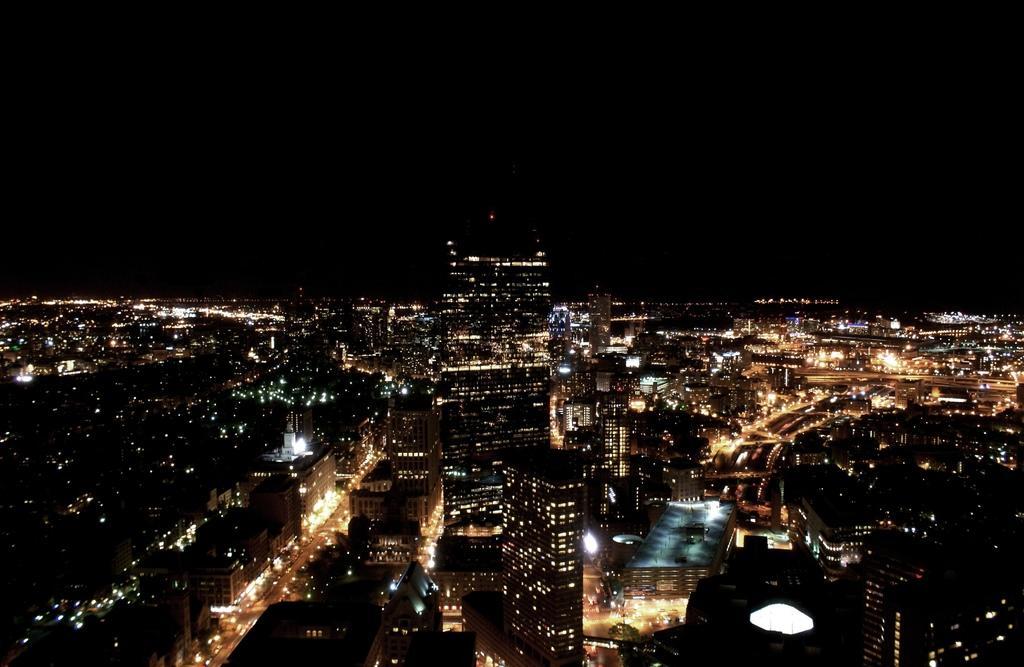In one or two sentences, can you explain what this image depicts? In this picture we can see buildings and lights. In the background of the image it is dark. 